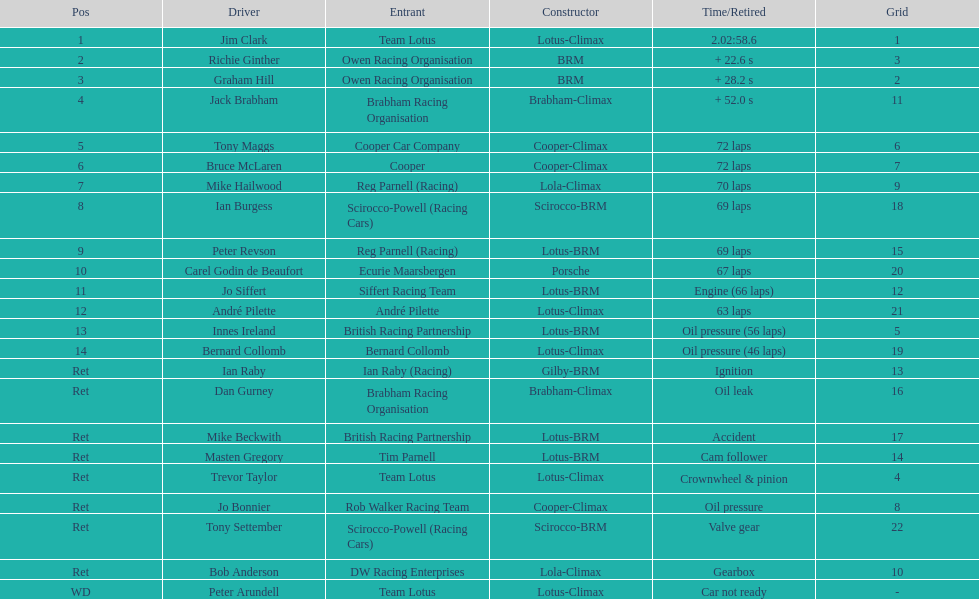Who are all the drivers? Jim Clark, Richie Ginther, Graham Hill, Jack Brabham, Tony Maggs, Bruce McLaren, Mike Hailwood, Ian Burgess, Peter Revson, Carel Godin de Beaufort, Jo Siffert, André Pilette, Innes Ireland, Bernard Collomb, Ian Raby, Dan Gurney, Mike Beckwith, Masten Gregory, Trevor Taylor, Jo Bonnier, Tony Settember, Bob Anderson, Peter Arundell. Which drove a cooper-climax? Tony Maggs, Bruce McLaren, Jo Bonnier. Of those, who was the top finisher? Tony Maggs. 